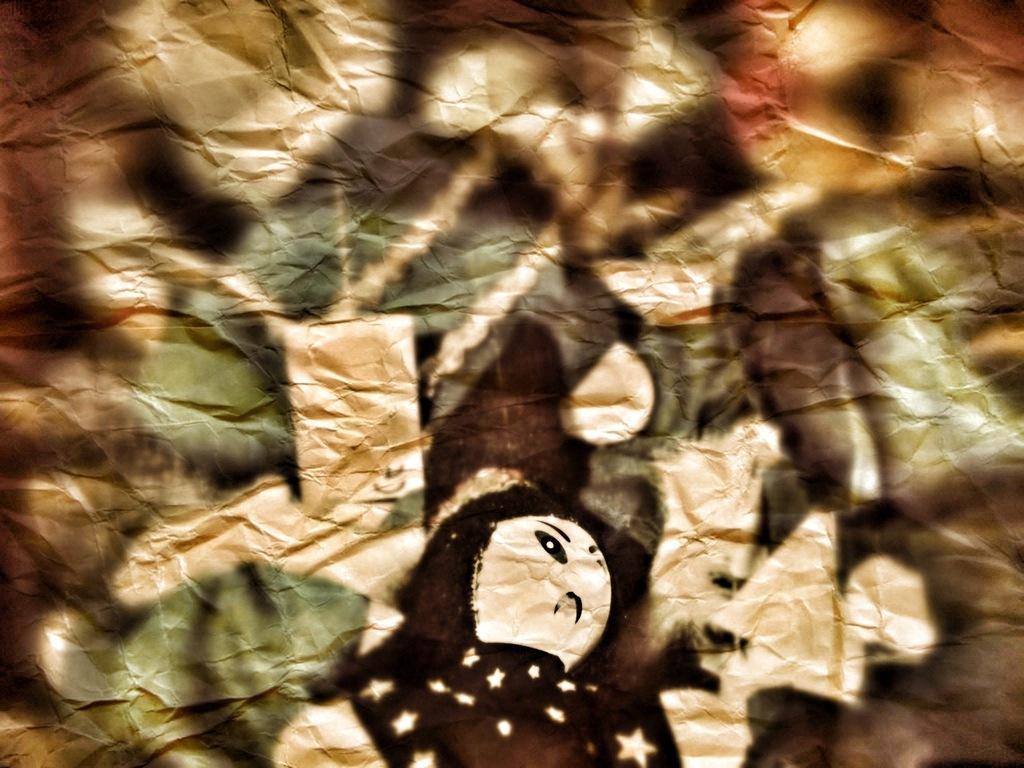What medium is used for the artwork in the image? The image is a painting on paper. How many goats are depicted in the painting? There are no goats present in the image, as it is a painting on paper and not a representation of any specific scene or subject matter. 